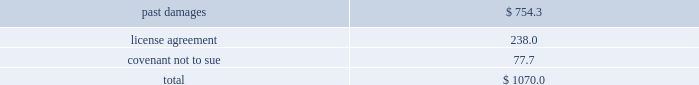Edwards lifesciences corporation notes to consolidated financial statements ( continued ) 2 .
Summary of significant accounting policies ( continued ) in may 2014 , the fasb issued an update to the accounting guidance on revenue recognition .
The new guidance provides a comprehensive , principles-based approach to revenue recognition , and supersedes most previous revenue recognition guidance .
The core principle of the guidance is that an entity should recognize revenue to depict the transfer of promised goods or services to customers in an amount that reflects the consideration to which the entity expects to be entitled in exchange for those goods or services .
The guidance also requires improved disclosures on the nature , amount , timing , and uncertainty of revenue that is recognized .
In august 2015 , the fasb issued an update to the guidance to defer the effective date by one year , such that the new standard will be effective for annual reporting periods beginning after december 15 , 2017 and interim periods therein .
The new guidance can be applied retrospectively to each prior reporting period presented , or retrospectively with the cumulative effect of the change recognized at the date of the initial application .
The company is assessing all of the potential impacts of the revenue recognition guidance and has not yet selected an adoption method .
The company will adopt the new guidance effective january 1 , although the company has not yet completed its assessment of the new revenue recognition guidance , the company 2019s analysis of contracts related to the sale of its heart valve therapy products under the new revenue recognition guidance supports the recognition of revenue at a point-in-time , which is consistent with its current revenue recognition model .
Heart valve therapy sales accounted for approximately 80% ( 80 % ) of the company 2019s sales for the year ended december 31 , 2016 .
The company is currently assessing the potential impact of the guidance on contracts related to the sale of its critical care products , specifically sales outside of the united states .
Intellectual property litigation expenses ( income ) , net in may 2014 , the company entered into an agreement with medtronic , inc .
And its affiliates ( 2018 2018medtronic 2019 2019 ) to settle all outstanding patent litigation between the companies , including all cases related to transcatheter heart valves .
Pursuant to the agreement , all pending cases or appeals in courts and patent offices worldwide have been dismissed , and the parties will not litigate patent disputes with each other in the field of transcatheter valves for the eight-year term of the agreement .
Under the terms of a patent cross-license that is part of the agreement , medtronic made a one-time , upfront payment to the company for past damages in the amount of $ 750.0 million .
In addition , medtronic will pay the company quarterly license royalty payments through april 2022 .
For sales in the united states , subject to certain conditions , the royalty payments will be based on a percentage of medtronic 2019s sales of transcatheter aortic valves , with a minimum annual payment of $ 40.0 million and a maximum annual payment of $ 60.0 million .
A separate royalty payment will be calculated based on sales of medtronic transcatheter aortic valves manufactured in the united states but sold elsewhere .
The company accounted for the settlement agreement as a multiple-element arrangement and allocated the total consideration to the identifiable elements based upon their relative fair value .
The consideration assigned to each element was as follows ( in millions ) : .

What percentage of the settlement was due to past damages? 
Computations: (754.3 / 1070.0)
Answer: 0.70495. 